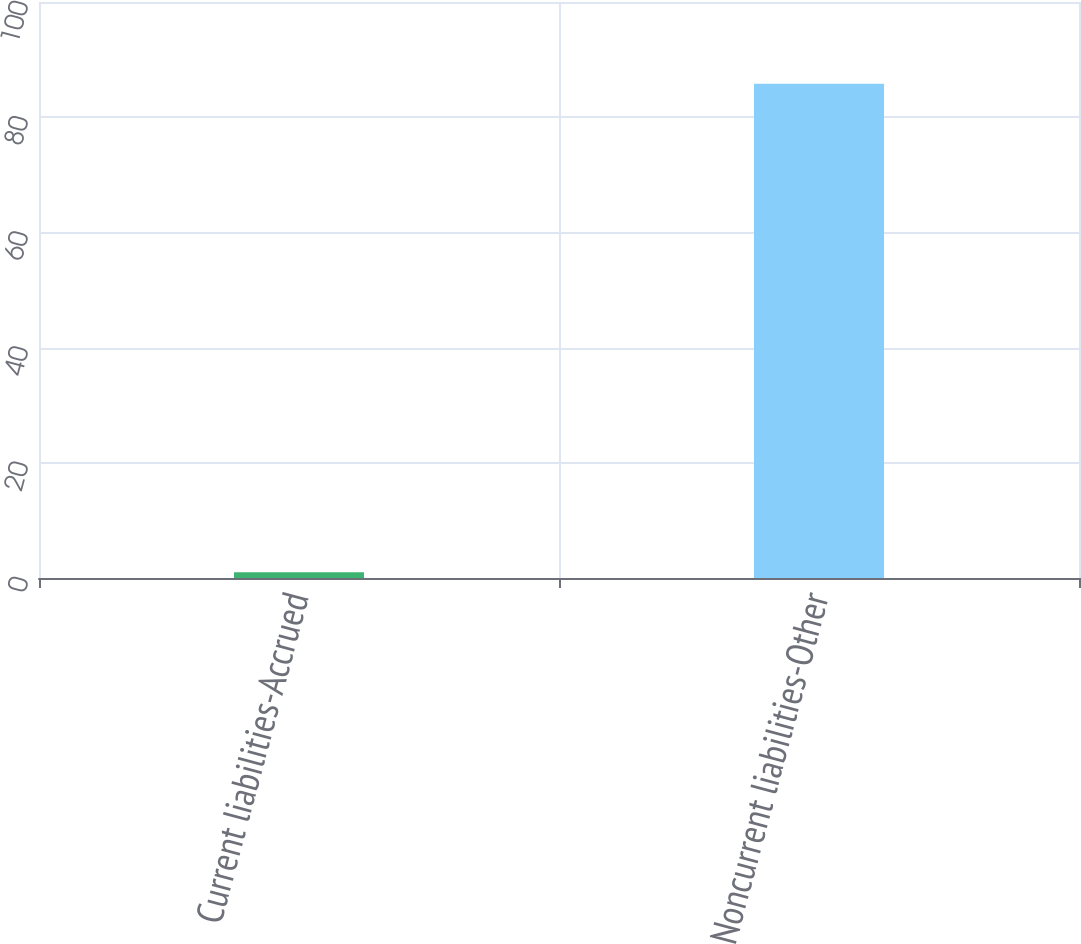Convert chart to OTSL. <chart><loc_0><loc_0><loc_500><loc_500><bar_chart><fcel>Current liabilities-Accrued<fcel>Noncurrent liabilities-Other<nl><fcel>1<fcel>85.8<nl></chart> 